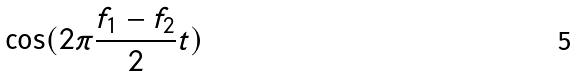Convert formula to latex. <formula><loc_0><loc_0><loc_500><loc_500>\cos ( 2 \pi \frac { f _ { 1 } - f _ { 2 } } { 2 } t )</formula> 